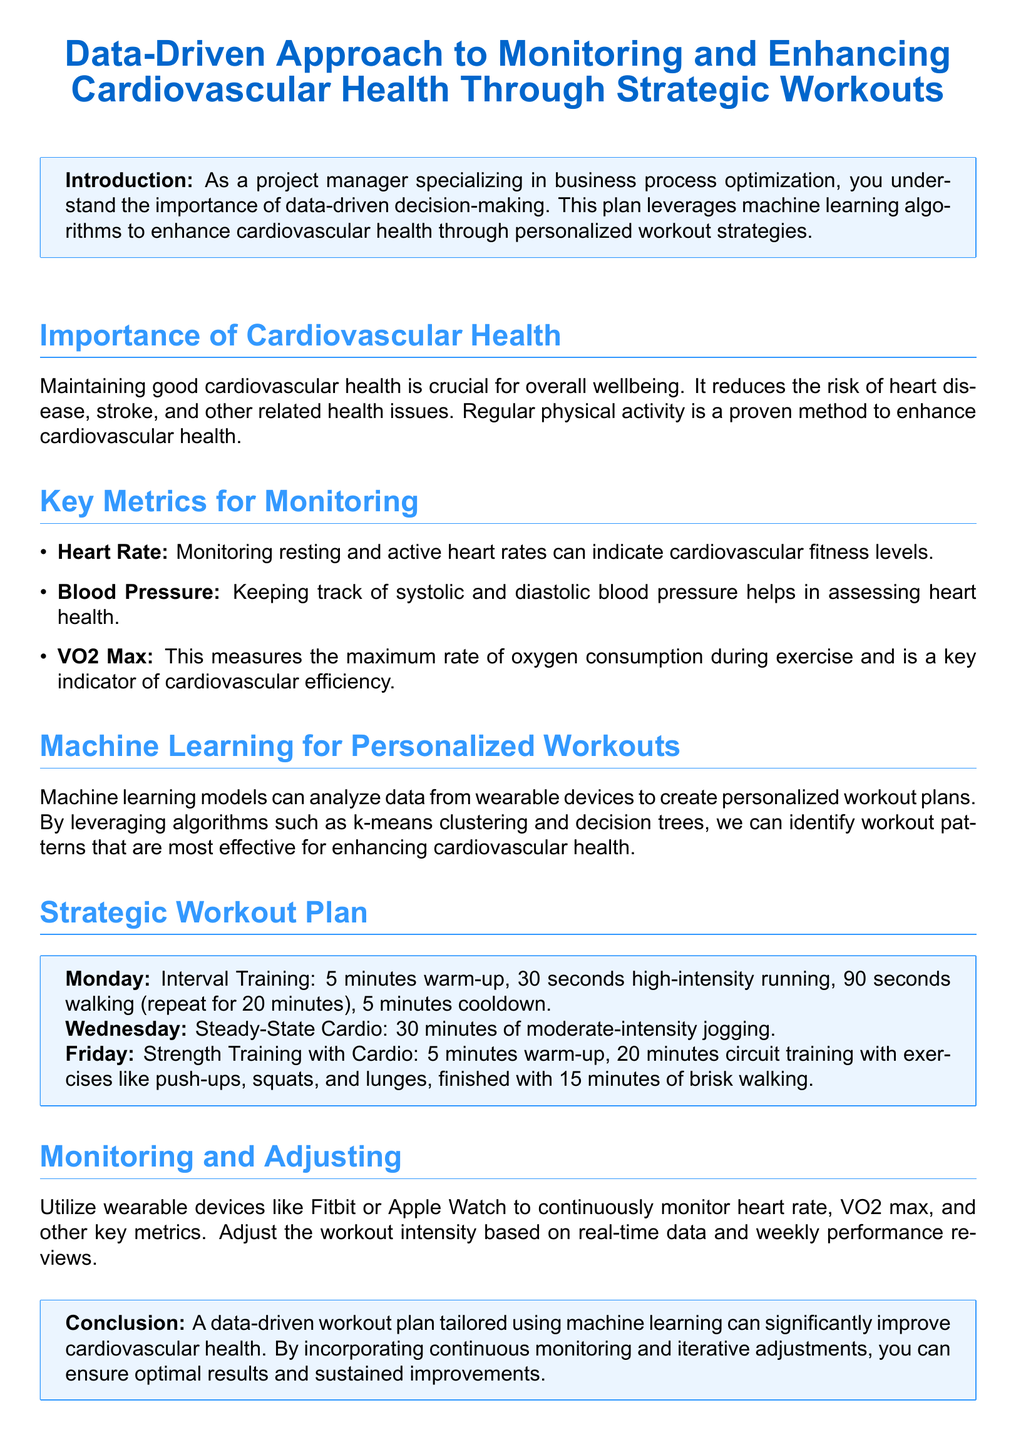What is the title of the document? The title is presented prominently at the top of the document and reads "Data-Driven Approach to Monitoring and Enhancing Cardiovascular Health Through Strategic Workouts."
Answer: Data-Driven Approach to Monitoring and Enhancing Cardiovascular Health Through Strategic Workouts What are the three key metrics for monitoring cardiovascular health? The document lists three specific metrics: heart rate, blood pressure, and VO2 Max as crucial for monitoring cardiovascular health.
Answer: Heart Rate, Blood Pressure, VO2 Max What type of workout is scheduled for Monday? The document specifies the type of workout planned for Monday as interval training.
Answer: Interval Training How long is the steady-state cardio session on Wednesday? The workout plan details that the steady-state cardio session on Wednesday lasts for 30 minutes.
Answer: 30 minutes What wearable devices are mentioned for monitoring health metrics? The document mentions Fitbit and Apple Watch as examples of wearable devices used for continuous monitoring of health metrics.
Answer: Fitbit, Apple Watch What is the primary purpose of utilizing machine learning in the workout plan? The document describes the purpose of using machine learning as analyzing data from wearable devices to create personalized workout plans.
Answer: Personalized workout plans How many minutes of cooldown are included in the Monday workout? The Monday workout plan includes a cooldown of 5 minutes at the end of the interval training.
Answer: 5 minutes What is the conclusion of the document regarding the workout plan? The conclusion reinforces the significance of a data-driven workout plan tailored using machine learning for improving cardiovascular health.
Answer: Improve cardiovascular health 